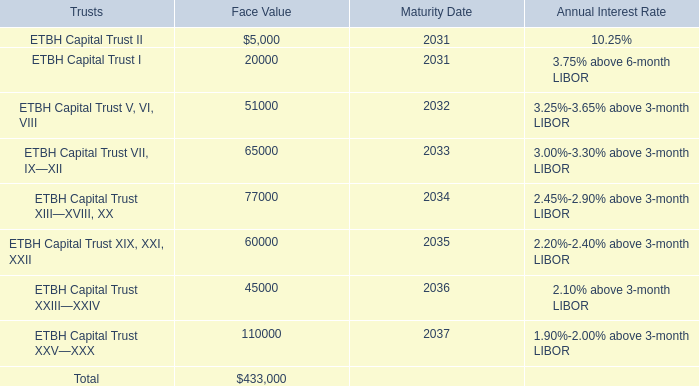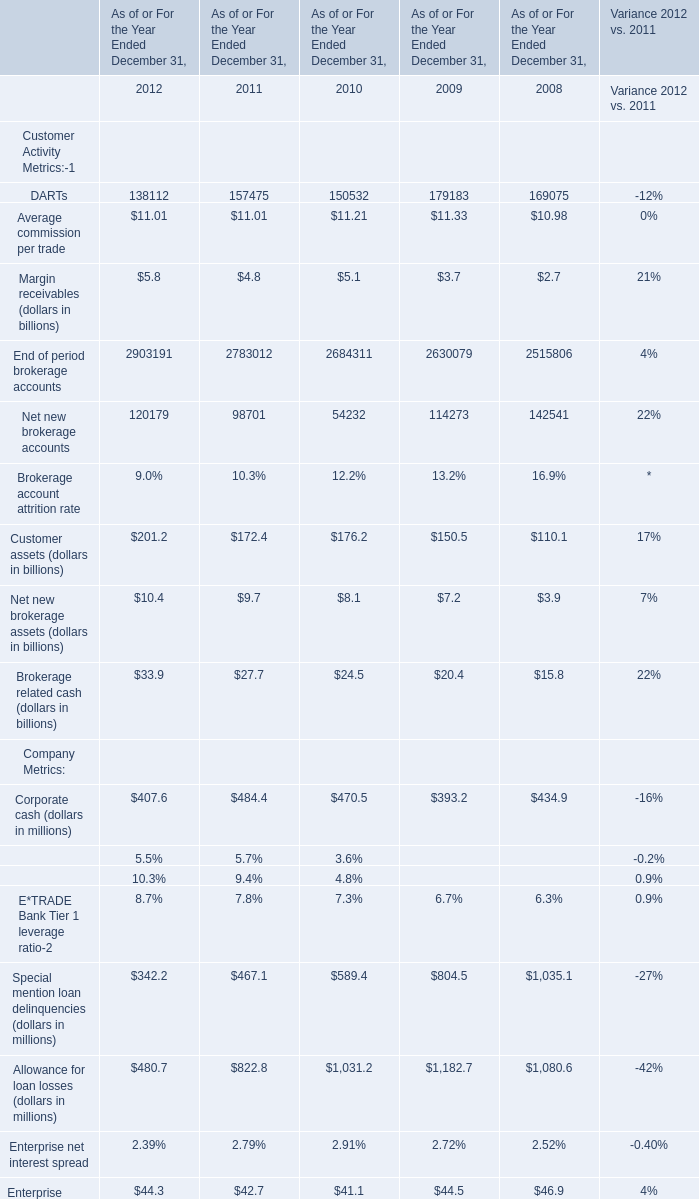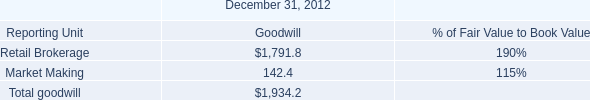In the year with largest amount of Average commission per trade, what's the increasing rate of Net new brokerage accounts? 
Computations: ((114273 - 142541) / 142541)
Answer: -0.19831. 